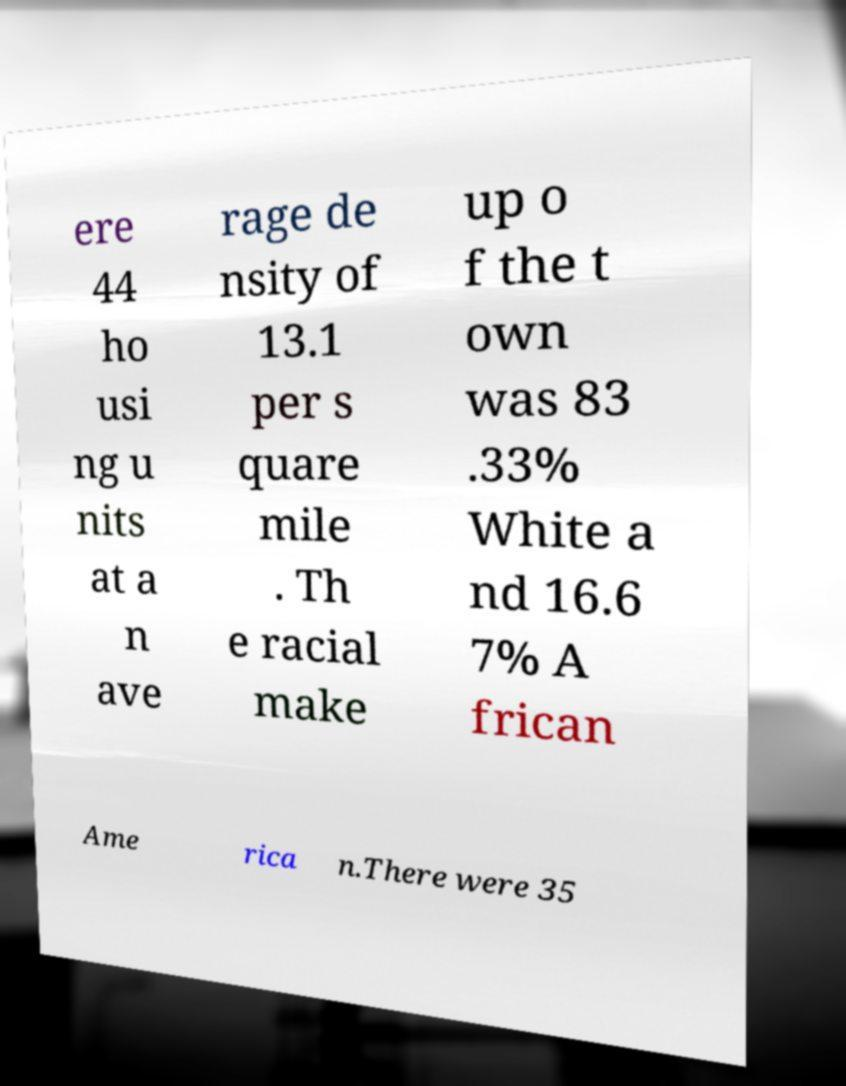What messages or text are displayed in this image? I need them in a readable, typed format. ere 44 ho usi ng u nits at a n ave rage de nsity of 13.1 per s quare mile . Th e racial make up o f the t own was 83 .33% White a nd 16.6 7% A frican Ame rica n.There were 35 